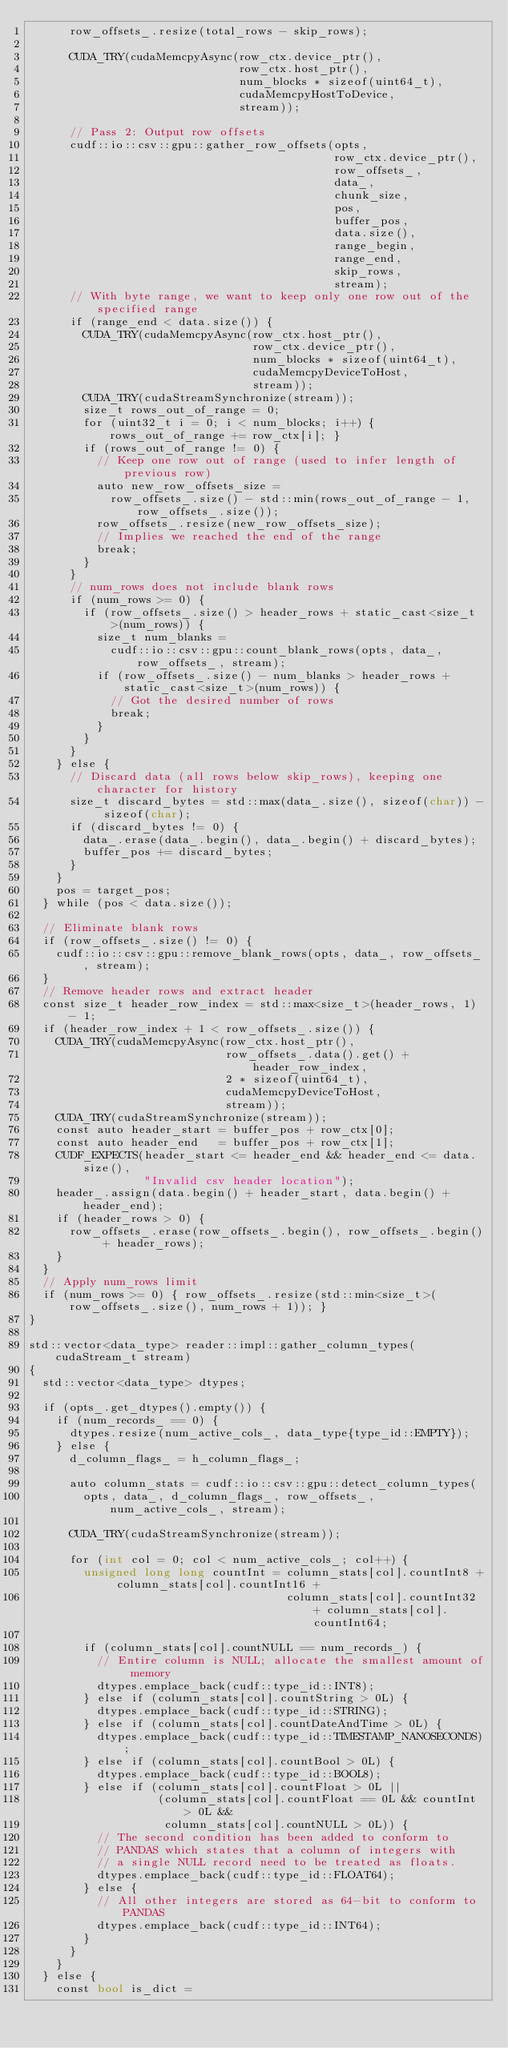Convert code to text. <code><loc_0><loc_0><loc_500><loc_500><_Cuda_>      row_offsets_.resize(total_rows - skip_rows);

      CUDA_TRY(cudaMemcpyAsync(row_ctx.device_ptr(),
                               row_ctx.host_ptr(),
                               num_blocks * sizeof(uint64_t),
                               cudaMemcpyHostToDevice,
                               stream));

      // Pass 2: Output row offsets
      cudf::io::csv::gpu::gather_row_offsets(opts,
                                             row_ctx.device_ptr(),
                                             row_offsets_,
                                             data_,
                                             chunk_size,
                                             pos,
                                             buffer_pos,
                                             data.size(),
                                             range_begin,
                                             range_end,
                                             skip_rows,
                                             stream);
      // With byte range, we want to keep only one row out of the specified range
      if (range_end < data.size()) {
        CUDA_TRY(cudaMemcpyAsync(row_ctx.host_ptr(),
                                 row_ctx.device_ptr(),
                                 num_blocks * sizeof(uint64_t),
                                 cudaMemcpyDeviceToHost,
                                 stream));
        CUDA_TRY(cudaStreamSynchronize(stream));
        size_t rows_out_of_range = 0;
        for (uint32_t i = 0; i < num_blocks; i++) { rows_out_of_range += row_ctx[i]; }
        if (rows_out_of_range != 0) {
          // Keep one row out of range (used to infer length of previous row)
          auto new_row_offsets_size =
            row_offsets_.size() - std::min(rows_out_of_range - 1, row_offsets_.size());
          row_offsets_.resize(new_row_offsets_size);
          // Implies we reached the end of the range
          break;
        }
      }
      // num_rows does not include blank rows
      if (num_rows >= 0) {
        if (row_offsets_.size() > header_rows + static_cast<size_t>(num_rows)) {
          size_t num_blanks =
            cudf::io::csv::gpu::count_blank_rows(opts, data_, row_offsets_, stream);
          if (row_offsets_.size() - num_blanks > header_rows + static_cast<size_t>(num_rows)) {
            // Got the desired number of rows
            break;
          }
        }
      }
    } else {
      // Discard data (all rows below skip_rows), keeping one character for history
      size_t discard_bytes = std::max(data_.size(), sizeof(char)) - sizeof(char);
      if (discard_bytes != 0) {
        data_.erase(data_.begin(), data_.begin() + discard_bytes);
        buffer_pos += discard_bytes;
      }
    }
    pos = target_pos;
  } while (pos < data.size());

  // Eliminate blank rows
  if (row_offsets_.size() != 0) {
    cudf::io::csv::gpu::remove_blank_rows(opts, data_, row_offsets_, stream);
  }
  // Remove header rows and extract header
  const size_t header_row_index = std::max<size_t>(header_rows, 1) - 1;
  if (header_row_index + 1 < row_offsets_.size()) {
    CUDA_TRY(cudaMemcpyAsync(row_ctx.host_ptr(),
                             row_offsets_.data().get() + header_row_index,
                             2 * sizeof(uint64_t),
                             cudaMemcpyDeviceToHost,
                             stream));
    CUDA_TRY(cudaStreamSynchronize(stream));
    const auto header_start = buffer_pos + row_ctx[0];
    const auto header_end   = buffer_pos + row_ctx[1];
    CUDF_EXPECTS(header_start <= header_end && header_end <= data.size(),
                 "Invalid csv header location");
    header_.assign(data.begin() + header_start, data.begin() + header_end);
    if (header_rows > 0) {
      row_offsets_.erase(row_offsets_.begin(), row_offsets_.begin() + header_rows);
    }
  }
  // Apply num_rows limit
  if (num_rows >= 0) { row_offsets_.resize(std::min<size_t>(row_offsets_.size(), num_rows + 1)); }
}

std::vector<data_type> reader::impl::gather_column_types(cudaStream_t stream)
{
  std::vector<data_type> dtypes;

  if (opts_.get_dtypes().empty()) {
    if (num_records_ == 0) {
      dtypes.resize(num_active_cols_, data_type{type_id::EMPTY});
    } else {
      d_column_flags_ = h_column_flags_;

      auto column_stats = cudf::io::csv::gpu::detect_column_types(
        opts, data_, d_column_flags_, row_offsets_, num_active_cols_, stream);

      CUDA_TRY(cudaStreamSynchronize(stream));

      for (int col = 0; col < num_active_cols_; col++) {
        unsigned long long countInt = column_stats[col].countInt8 + column_stats[col].countInt16 +
                                      column_stats[col].countInt32 + column_stats[col].countInt64;

        if (column_stats[col].countNULL == num_records_) {
          // Entire column is NULL; allocate the smallest amount of memory
          dtypes.emplace_back(cudf::type_id::INT8);
        } else if (column_stats[col].countString > 0L) {
          dtypes.emplace_back(cudf::type_id::STRING);
        } else if (column_stats[col].countDateAndTime > 0L) {
          dtypes.emplace_back(cudf::type_id::TIMESTAMP_NANOSECONDS);
        } else if (column_stats[col].countBool > 0L) {
          dtypes.emplace_back(cudf::type_id::BOOL8);
        } else if (column_stats[col].countFloat > 0L ||
                   (column_stats[col].countFloat == 0L && countInt > 0L &&
                    column_stats[col].countNULL > 0L)) {
          // The second condition has been added to conform to
          // PANDAS which states that a column of integers with
          // a single NULL record need to be treated as floats.
          dtypes.emplace_back(cudf::type_id::FLOAT64);
        } else {
          // All other integers are stored as 64-bit to conform to PANDAS
          dtypes.emplace_back(cudf::type_id::INT64);
        }
      }
    }
  } else {
    const bool is_dict =</code> 